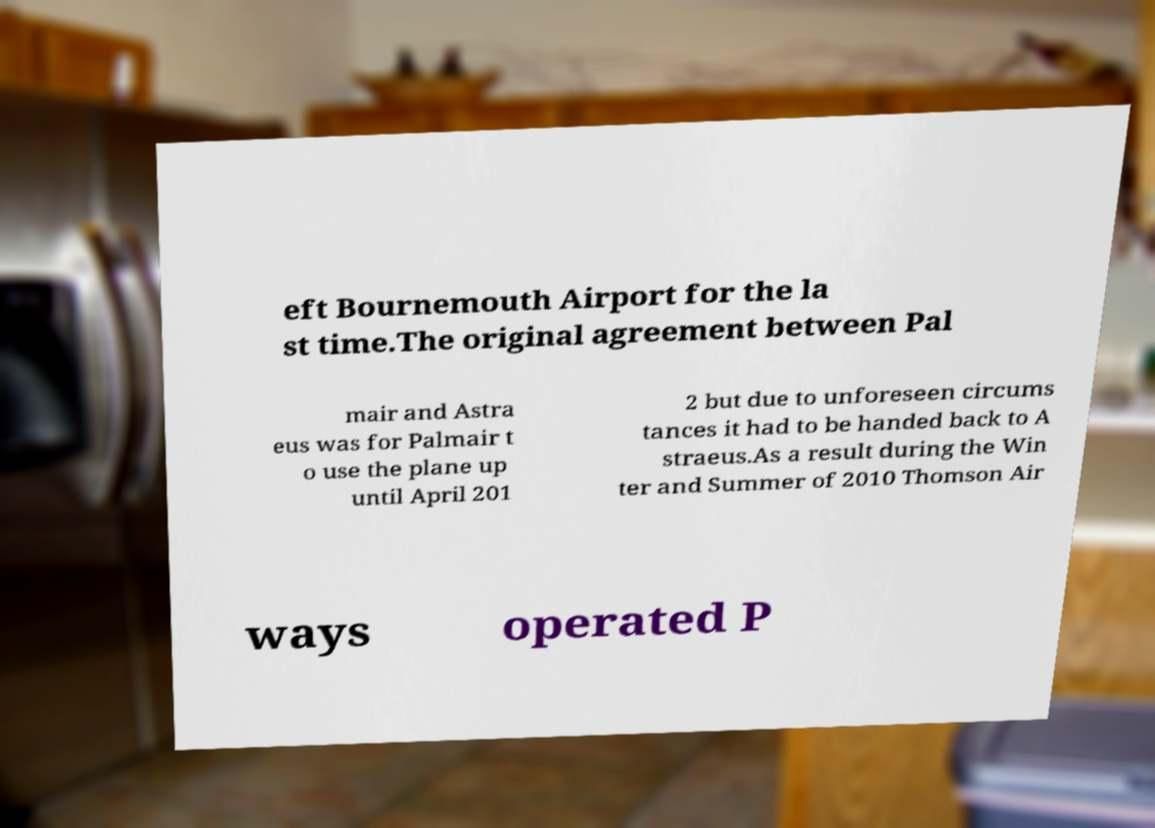There's text embedded in this image that I need extracted. Can you transcribe it verbatim? eft Bournemouth Airport for the la st time.The original agreement between Pal mair and Astra eus was for Palmair t o use the plane up until April 201 2 but due to unforeseen circums tances it had to be handed back to A straeus.As a result during the Win ter and Summer of 2010 Thomson Air ways operated P 